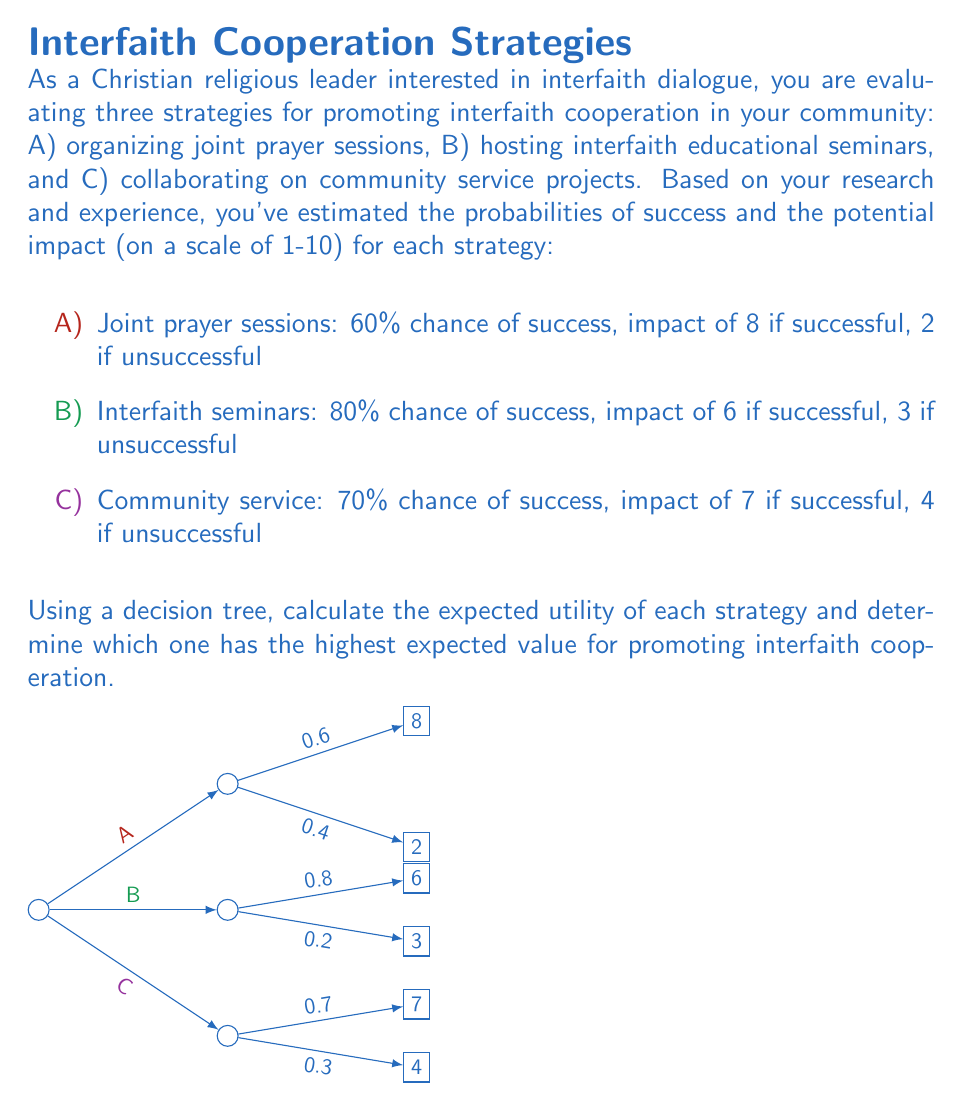Teach me how to tackle this problem. To solve this problem, we'll calculate the expected utility for each strategy using the decision tree method:

1. Strategy A: Joint prayer sessions
   Expected Utility = (Probability of success × Impact if successful) + (Probability of failure × Impact if unsuccessful)
   $EU_A = (0.60 \times 8) + (0.40 \times 2) = 4.8 + 0.8 = 5.6$

2. Strategy B: Interfaith educational seminars
   $EU_B = (0.80 \times 6) + (0.20 \times 3) = 4.8 + 0.6 = 5.4$

3. Strategy C: Community service projects
   $EU_C = (0.70 \times 7) + (0.30 \times 4) = 4.9 + 1.2 = 6.1$

To determine which strategy has the highest expected value, we compare the expected utilities:

$EU_A = 5.6$
$EU_B = 5.4$
$EU_C = 6.1$

Strategy C (Community service projects) has the highest expected utility of 6.1, making it the best choice for promoting interfaith cooperation based on the given probabilities and impact values.
Answer: Strategy C (Community service projects) with an expected utility of 6.1. 